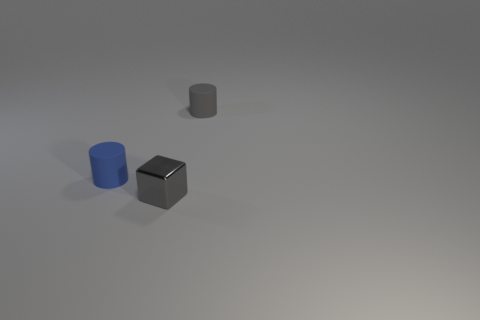Are there any other things that have the same material as the tiny block?
Provide a succinct answer. No. Is the small blue cylinder made of the same material as the gray cube?
Your answer should be compact. No. What number of other objects are the same shape as the gray rubber object?
Offer a very short reply. 1. How many objects are either tiny objects that are left of the gray rubber cylinder or blocks right of the tiny blue object?
Provide a succinct answer. 2. What number of blue cylinders are to the left of the tiny rubber thing to the left of the tiny cube?
Provide a succinct answer. 0. Is the shape of the tiny rubber thing that is in front of the tiny gray rubber cylinder the same as the gray object that is behind the tiny gray block?
Offer a very short reply. Yes. The other thing that is the same color as the shiny object is what shape?
Give a very brief answer. Cylinder. Is there another tiny cylinder that has the same material as the tiny gray cylinder?
Your response must be concise. Yes. How many shiny things are small blue cylinders or gray cubes?
Offer a terse response. 1. What shape is the matte thing that is right of the rubber thing to the left of the gray shiny block?
Your answer should be compact. Cylinder. 